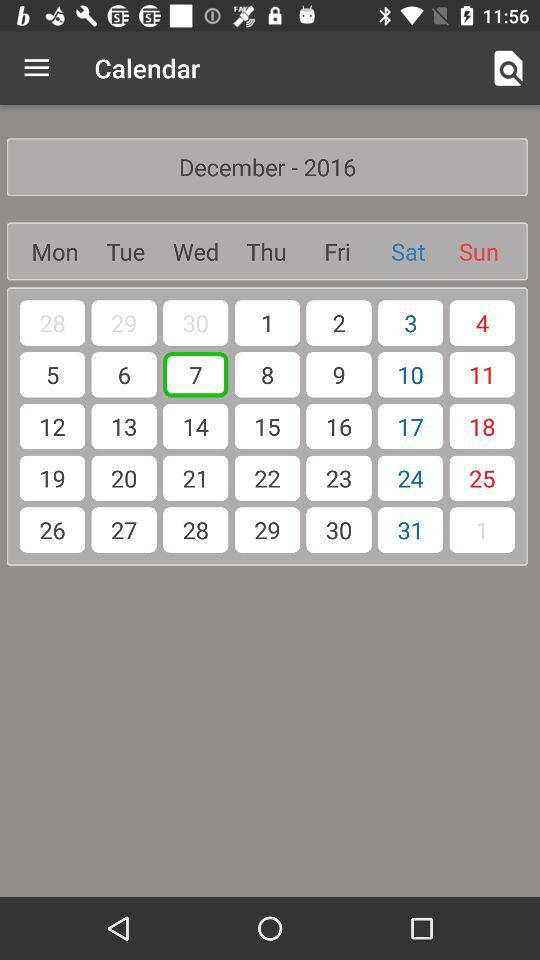Which day is on April 1, 2016?
When the provided information is insufficient, respond with <no answer>. <no answer> 